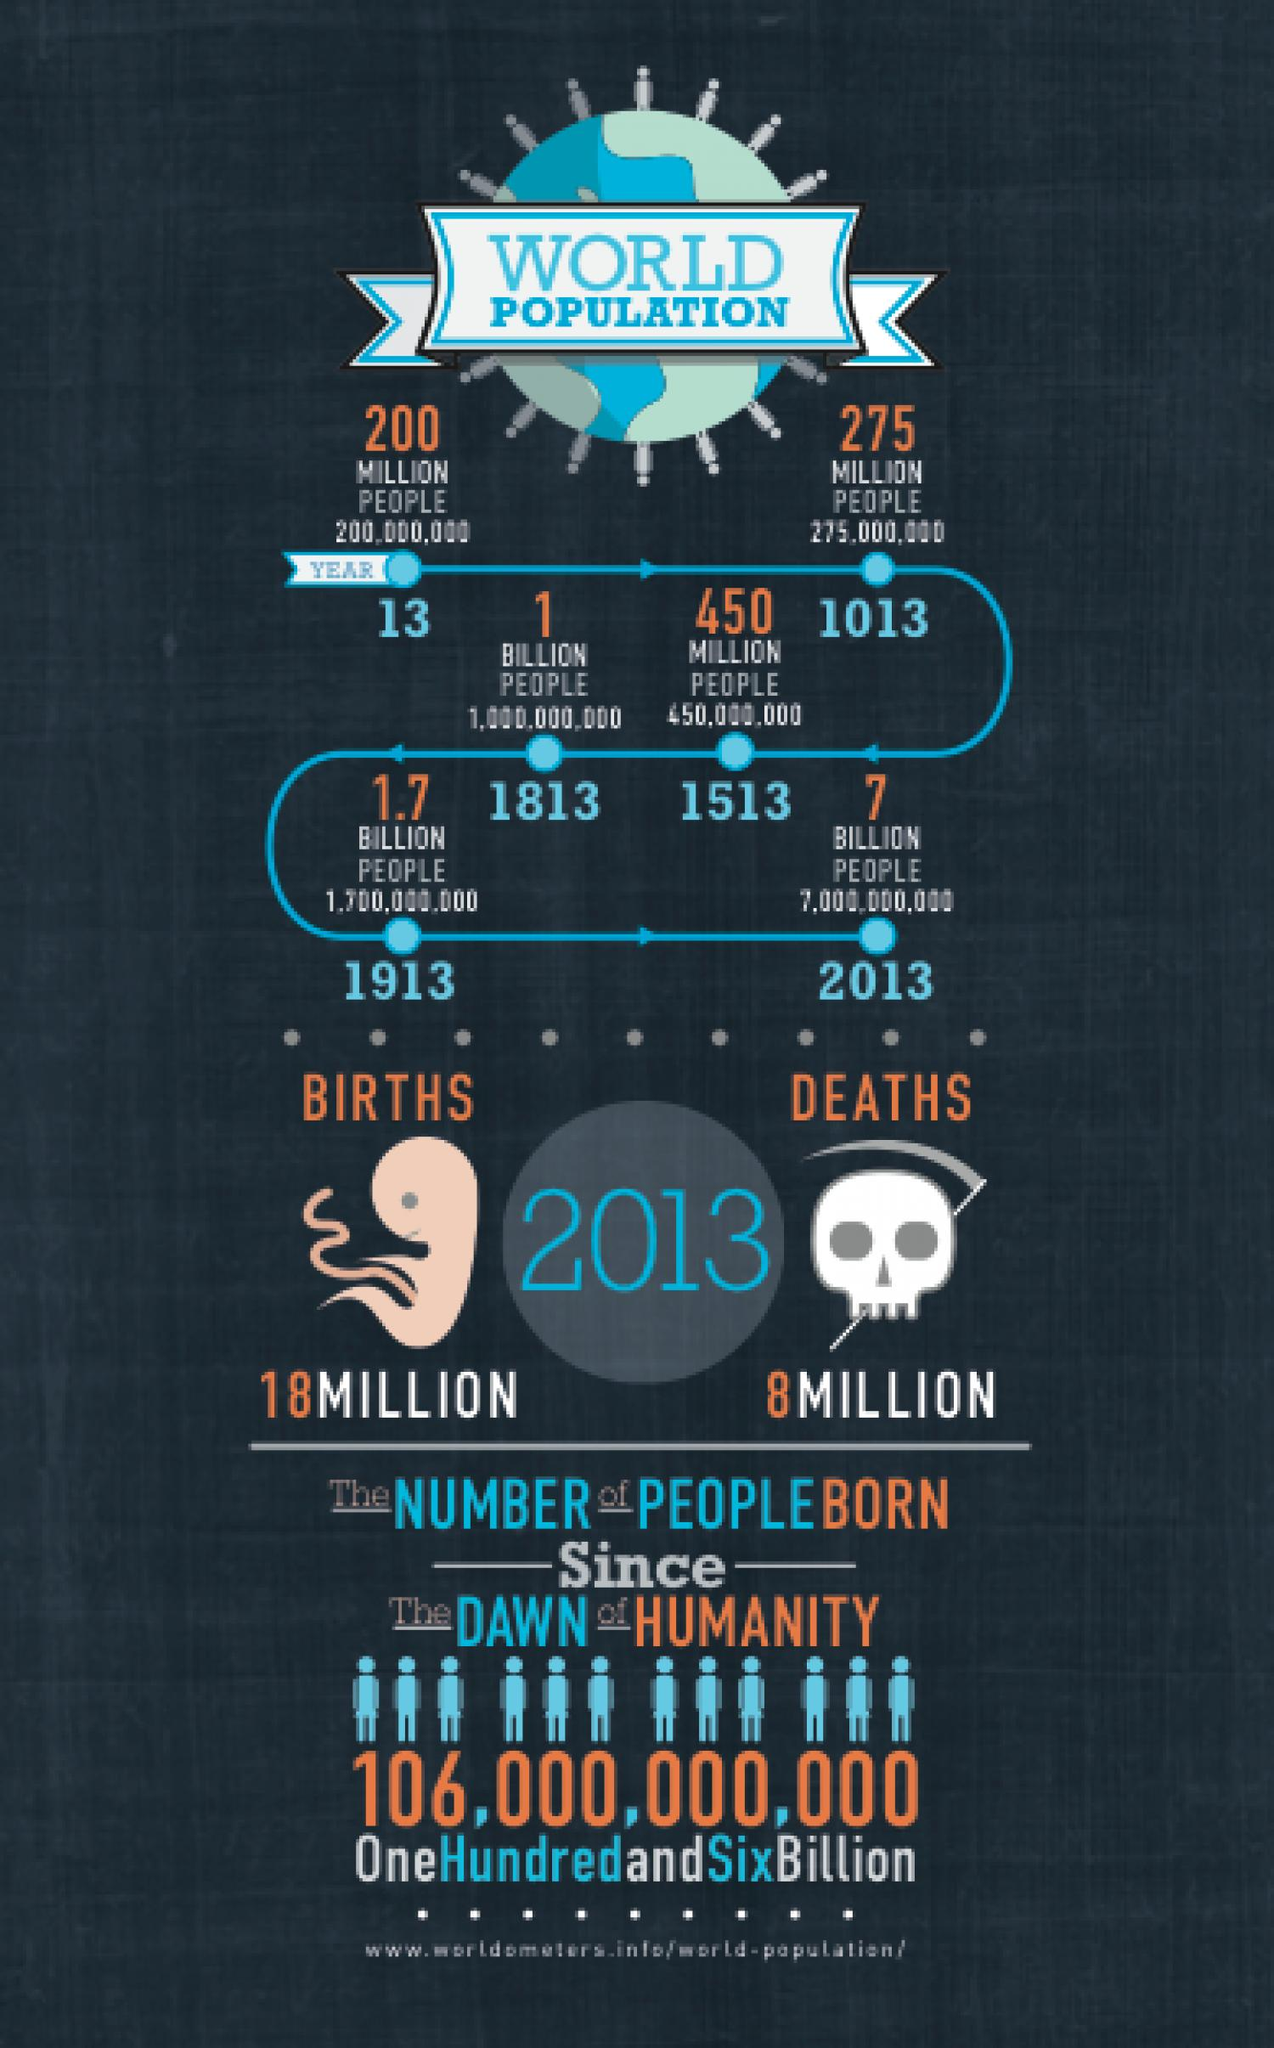Specify some key components in this picture. In 2013, there was a difference of approximately 10 million between the number of births and the number of deaths. 